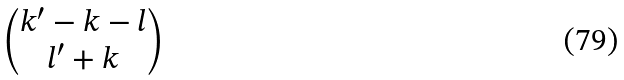Convert formula to latex. <formula><loc_0><loc_0><loc_500><loc_500>\begin{pmatrix} k ^ { \prime } - k - l \\ l ^ { \prime } + k \end{pmatrix}</formula> 